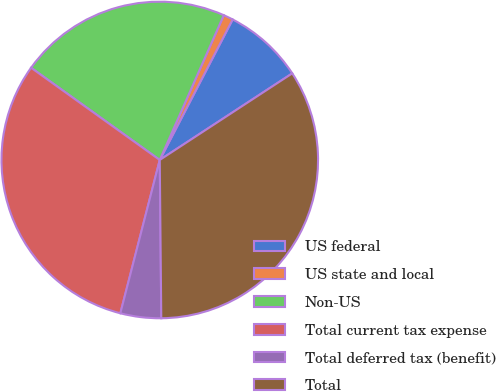Convert chart. <chart><loc_0><loc_0><loc_500><loc_500><pie_chart><fcel>US federal<fcel>US state and local<fcel>Non-US<fcel>Total current tax expense<fcel>Total deferred tax (benefit)<fcel>Total<nl><fcel>8.17%<fcel>0.99%<fcel>21.73%<fcel>30.89%<fcel>4.16%<fcel>34.06%<nl></chart> 